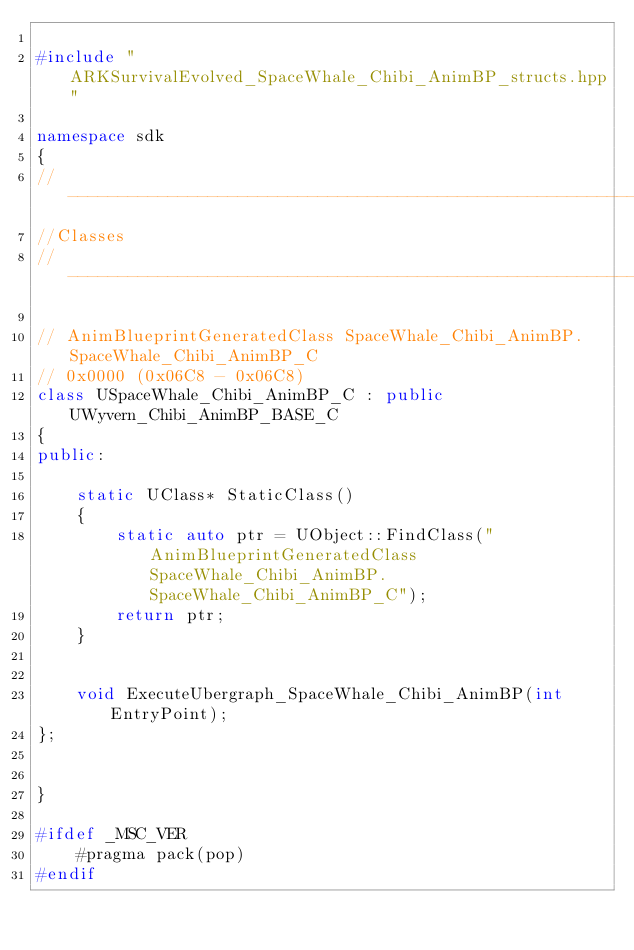Convert code to text. <code><loc_0><loc_0><loc_500><loc_500><_C++_>
#include "ARKSurvivalEvolved_SpaceWhale_Chibi_AnimBP_structs.hpp"

namespace sdk
{
//---------------------------------------------------------------------------
//Classes
//---------------------------------------------------------------------------

// AnimBlueprintGeneratedClass SpaceWhale_Chibi_AnimBP.SpaceWhale_Chibi_AnimBP_C
// 0x0000 (0x06C8 - 0x06C8)
class USpaceWhale_Chibi_AnimBP_C : public UWyvern_Chibi_AnimBP_BASE_C
{
public:

	static UClass* StaticClass()
	{
		static auto ptr = UObject::FindClass("AnimBlueprintGeneratedClass SpaceWhale_Chibi_AnimBP.SpaceWhale_Chibi_AnimBP_C");
		return ptr;
	}


	void ExecuteUbergraph_SpaceWhale_Chibi_AnimBP(int EntryPoint);
};


}

#ifdef _MSC_VER
	#pragma pack(pop)
#endif
</code> 